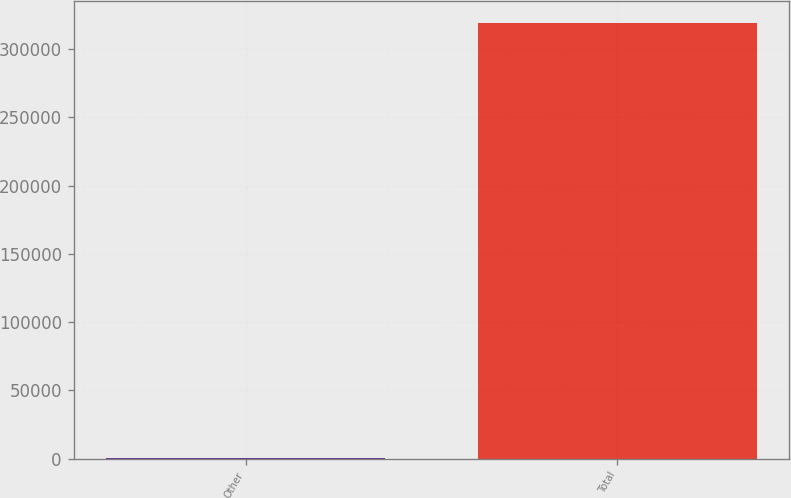Convert chart. <chart><loc_0><loc_0><loc_500><loc_500><bar_chart><fcel>Other<fcel>Total<nl><fcel>677<fcel>319569<nl></chart> 